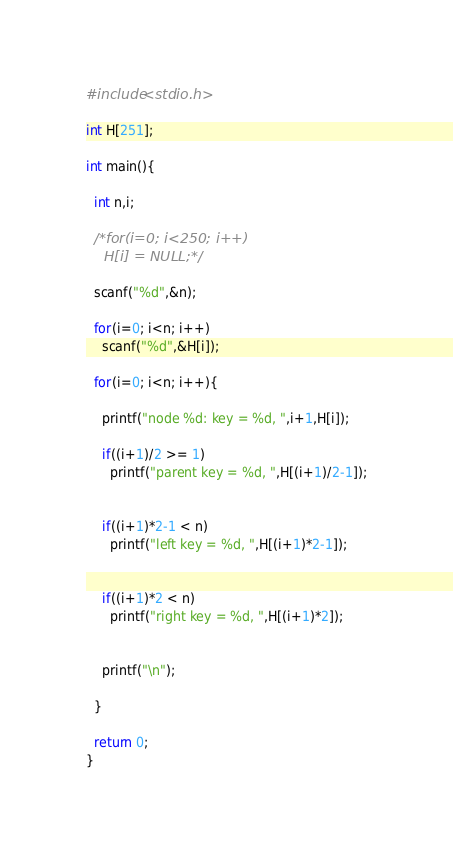Convert code to text. <code><loc_0><loc_0><loc_500><loc_500><_C_>#include<stdio.h>

int H[251];

int main(){

  int n,i;

  /*for(i=0; i<250; i++)
    H[i] = NULL;*/

  scanf("%d",&n);

  for(i=0; i<n; i++)
    scanf("%d",&H[i]);

  for(i=0; i<n; i++){

    printf("node %d: key = %d, ",i+1,H[i]);

    if((i+1)/2 >= 1)
      printf("parent key = %d, ",H[(i+1)/2-1]);
    
    
    if((i+1)*2-1 < n)
      printf("left key = %d, ",H[(i+1)*2-1]); 
    

    if((i+1)*2 < n)
      printf("right key = %d, ",H[(i+1)*2]);
    

    printf("\n");

  }

  return 0;
}</code> 